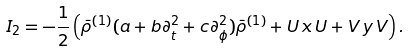Convert formula to latex. <formula><loc_0><loc_0><loc_500><loc_500>I _ { 2 } = - \frac { 1 } { 2 } \left ( \bar { \rho } ^ { ( 1 ) } ( a + b \partial _ { t } ^ { 2 } + c \partial _ { \phi } ^ { 2 } ) \bar { \rho } ^ { ( 1 ) } + U \, x \, U + V \, y \, V \right ) .</formula> 